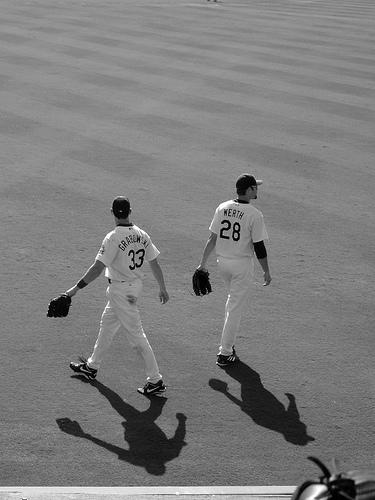Can you see shadows in the photo?
Write a very short answer. Yes. Do these guys like each other?
Be succinct. Yes. What is the number on the jersey?
Short answer required. 33 and 28. What type of uniforms are these men wearing?
Quick response, please. Baseball. Is he wearing tennis shoes?
Quick response, please. No. Are they having fun?
Quick response, please. Yes. What hand is the catcher tagging the runner with?
Be succinct. Right. 